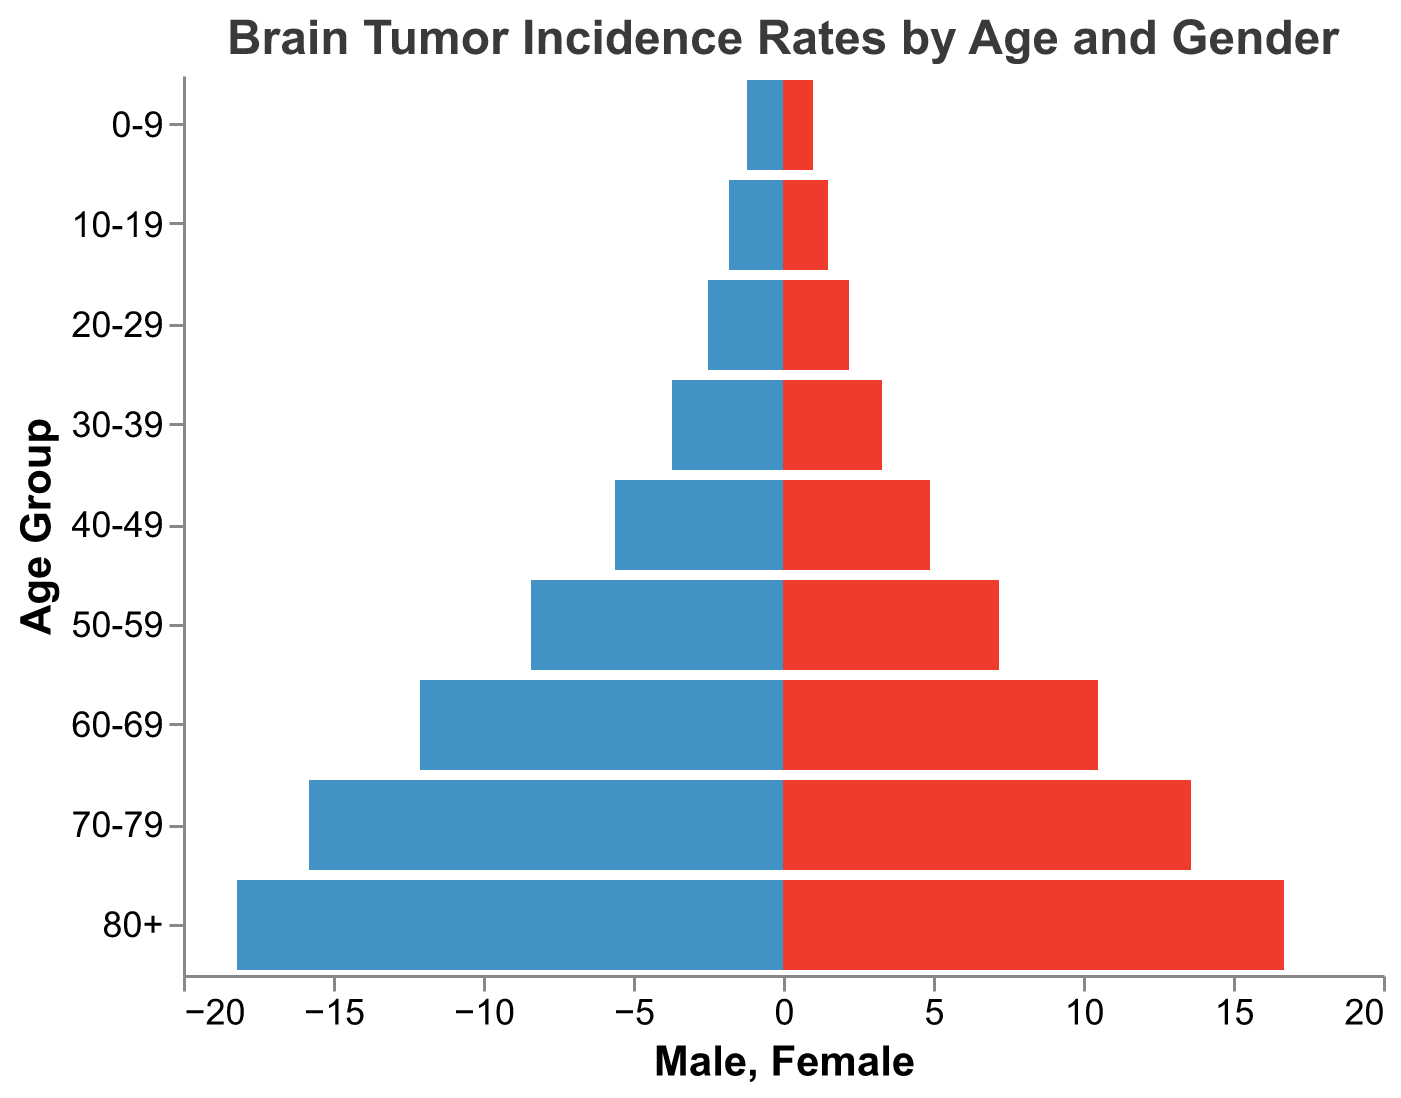What is the title of the figure? The title of the figure is provided at the top of the plot. It reads "Brain Tumor Incidence Rates by Age and Gender".
Answer: Brain Tumor Incidence Rates by Age and Gender What is the highest incidence rate for males? The highest incidence rate for males can be found by looking at the left side of the pyramid. The largest negative value is in the "80+" age group, which is 18.2.
Answer: 18.2 In which age group do females have the highest incidence rate? The highest incidence rate for females is observed by looking at the right side of the pyramid. The largest positive value for females is in the "80+" age group, which is 16.7.
Answer: 80+ What is the incidence rate difference between males and females in the 50-59 age group? For males, the incidence rate in the 50-59 age group is 8.4, and for females, it is 7.2. The difference is calculated as 8.4 - 7.2.
Answer: 1.2 Which age group shows the greatest disparity in incidence rates between males and females? To determine this, calculate the absolute difference in incidence rates for each age group and identify the largest value. The "80+" age group has the highest disparity with a difference of 1.5 (18.2 for males and 16.7 for females).
Answer: 80+ How do the incidence rates for both genders compare in the 20-29 age group? By examining the values for the 20-29 age group, males have an incidence rate of 2.5, whereas females have a rate of 2.2. The males have a slightly higher incidence rate in this group.
Answer: Males have a slightly higher incidence rate What is the trend in incidence rates for males across the age groups? The incidence rates for males increase steadily with age. Starting from 1.2 in the 0-9 age group and reaching 18.2 in the 80+ age group.
Answer: Steadily increases with age What is the average incidence rate for males? Add up all the incidence rates for males and divide by the number of age groups. The sum is 69.3 across 9 age groups. The average is 69.3/9.
Answer: 7.7 Is there any age group where the incidence rates are equal for both genders? By comparing the values for each age group, none of the age groups have equal incidence rates.
Answer: No What is the combined (male + female) incidence rate for the 60-69 age group? For the 60-69 age group, the male incidence rate is 12.1 and the female incidence rate is 10.5. Add them together for the combined rate.
Answer: 22.6 